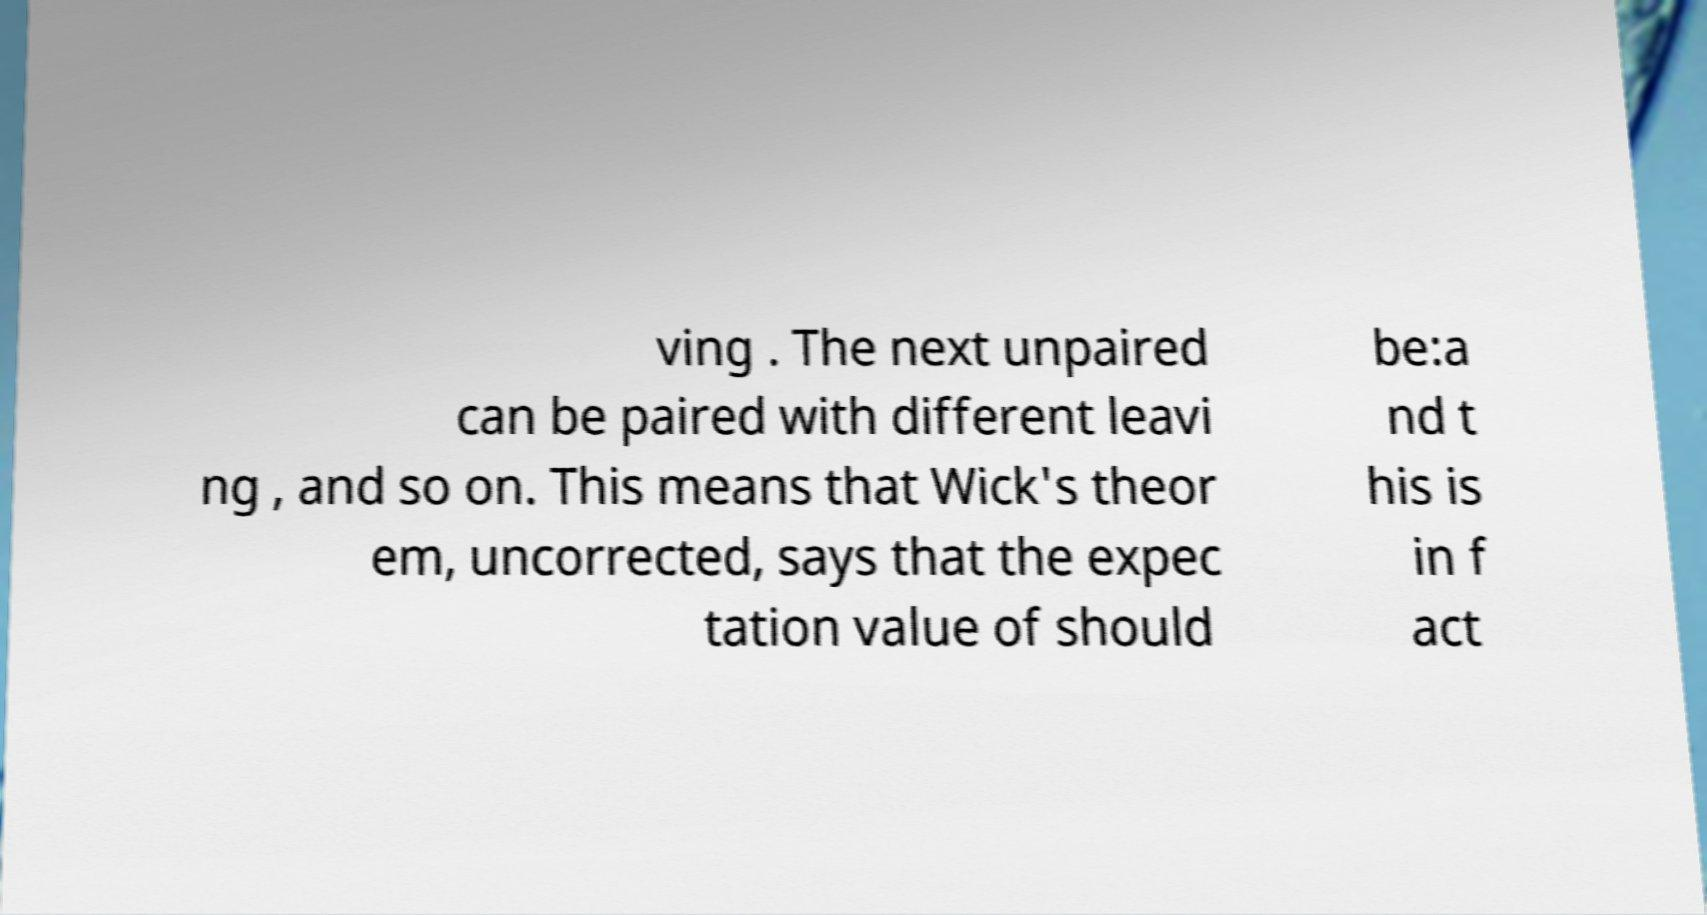I need the written content from this picture converted into text. Can you do that? ving . The next unpaired can be paired with different leavi ng , and so on. This means that Wick's theor em, uncorrected, says that the expec tation value of should be:a nd t his is in f act 